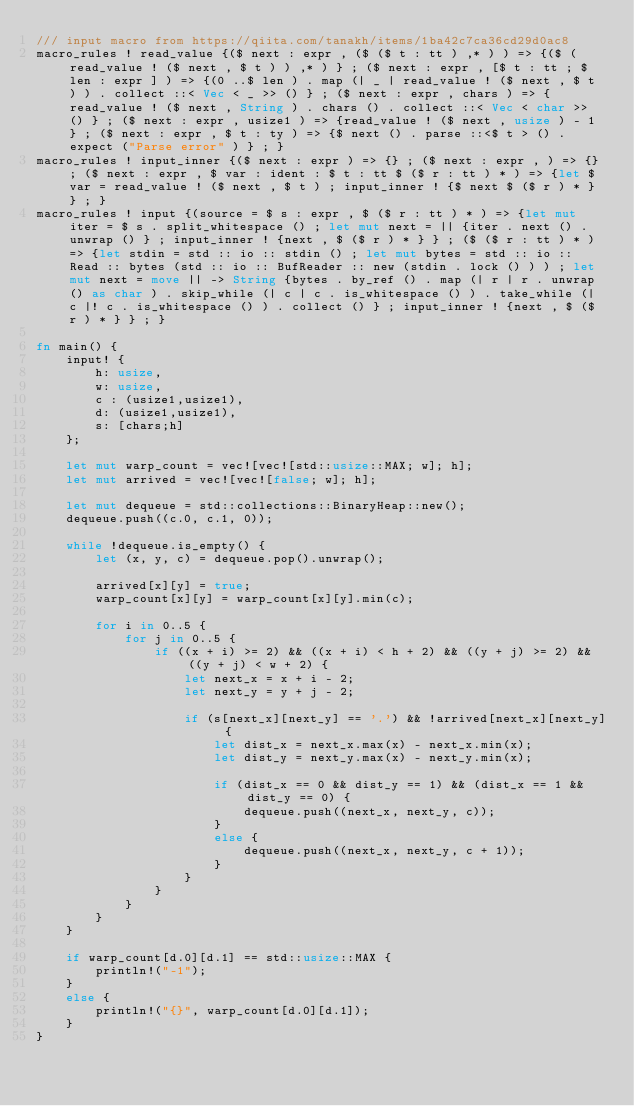Convert code to text. <code><loc_0><loc_0><loc_500><loc_500><_Rust_>/// input macro from https://qiita.com/tanakh/items/1ba42c7ca36cd29d0ac8
macro_rules ! read_value {($ next : expr , ($ ($ t : tt ) ,* ) ) => {($ (read_value ! ($ next , $ t ) ) ,* ) } ; ($ next : expr , [$ t : tt ; $ len : expr ] ) => {(0 ..$ len ) . map (| _ | read_value ! ($ next , $ t ) ) . collect ::< Vec < _ >> () } ; ($ next : expr , chars ) => {read_value ! ($ next , String ) . chars () . collect ::< Vec < char >> () } ; ($ next : expr , usize1 ) => {read_value ! ($ next , usize ) - 1 } ; ($ next : expr , $ t : ty ) => {$ next () . parse ::<$ t > () . expect ("Parse error" ) } ; }
macro_rules ! input_inner {($ next : expr ) => {} ; ($ next : expr , ) => {} ; ($ next : expr , $ var : ident : $ t : tt $ ($ r : tt ) * ) => {let $ var = read_value ! ($ next , $ t ) ; input_inner ! {$ next $ ($ r ) * } } ; }
macro_rules ! input {(source = $ s : expr , $ ($ r : tt ) * ) => {let mut iter = $ s . split_whitespace () ; let mut next = || {iter . next () . unwrap () } ; input_inner ! {next , $ ($ r ) * } } ; ($ ($ r : tt ) * ) => {let stdin = std :: io :: stdin () ; let mut bytes = std :: io :: Read :: bytes (std :: io :: BufReader :: new (stdin . lock () ) ) ; let mut next = move || -> String {bytes . by_ref () . map (| r | r . unwrap () as char ) . skip_while (| c | c . is_whitespace () ) . take_while (| c |! c . is_whitespace () ) . collect () } ; input_inner ! {next , $ ($ r ) * } } ; }

fn main() {
    input! {
        h: usize,
        w: usize,
        c : (usize1,usize1),
        d: (usize1,usize1),
        s: [chars;h]
    };

    let mut warp_count = vec![vec![std::usize::MAX; w]; h];
    let mut arrived = vec![vec![false; w]; h];

    let mut dequeue = std::collections::BinaryHeap::new();
    dequeue.push((c.0, c.1, 0));

    while !dequeue.is_empty() {
        let (x, y, c) = dequeue.pop().unwrap();

        arrived[x][y] = true;
        warp_count[x][y] = warp_count[x][y].min(c);

        for i in 0..5 {
            for j in 0..5 {
                if ((x + i) >= 2) && ((x + i) < h + 2) && ((y + j) >= 2) && ((y + j) < w + 2) {
                    let next_x = x + i - 2;
                    let next_y = y + j - 2;

                    if (s[next_x][next_y] == '.') && !arrived[next_x][next_y] {
                        let dist_x = next_x.max(x) - next_x.min(x);
                        let dist_y = next_y.max(x) - next_y.min(x);

                        if (dist_x == 0 && dist_y == 1) && (dist_x == 1 && dist_y == 0) {
                            dequeue.push((next_x, next_y, c));
                        }
                        else {
                            dequeue.push((next_x, next_y, c + 1));
                        }
                    }
                }
            }
        }
    }

    if warp_count[d.0][d.1] == std::usize::MAX {
        println!("-1");
    }
    else {
        println!("{}", warp_count[d.0][d.1]);
    }
}
</code> 